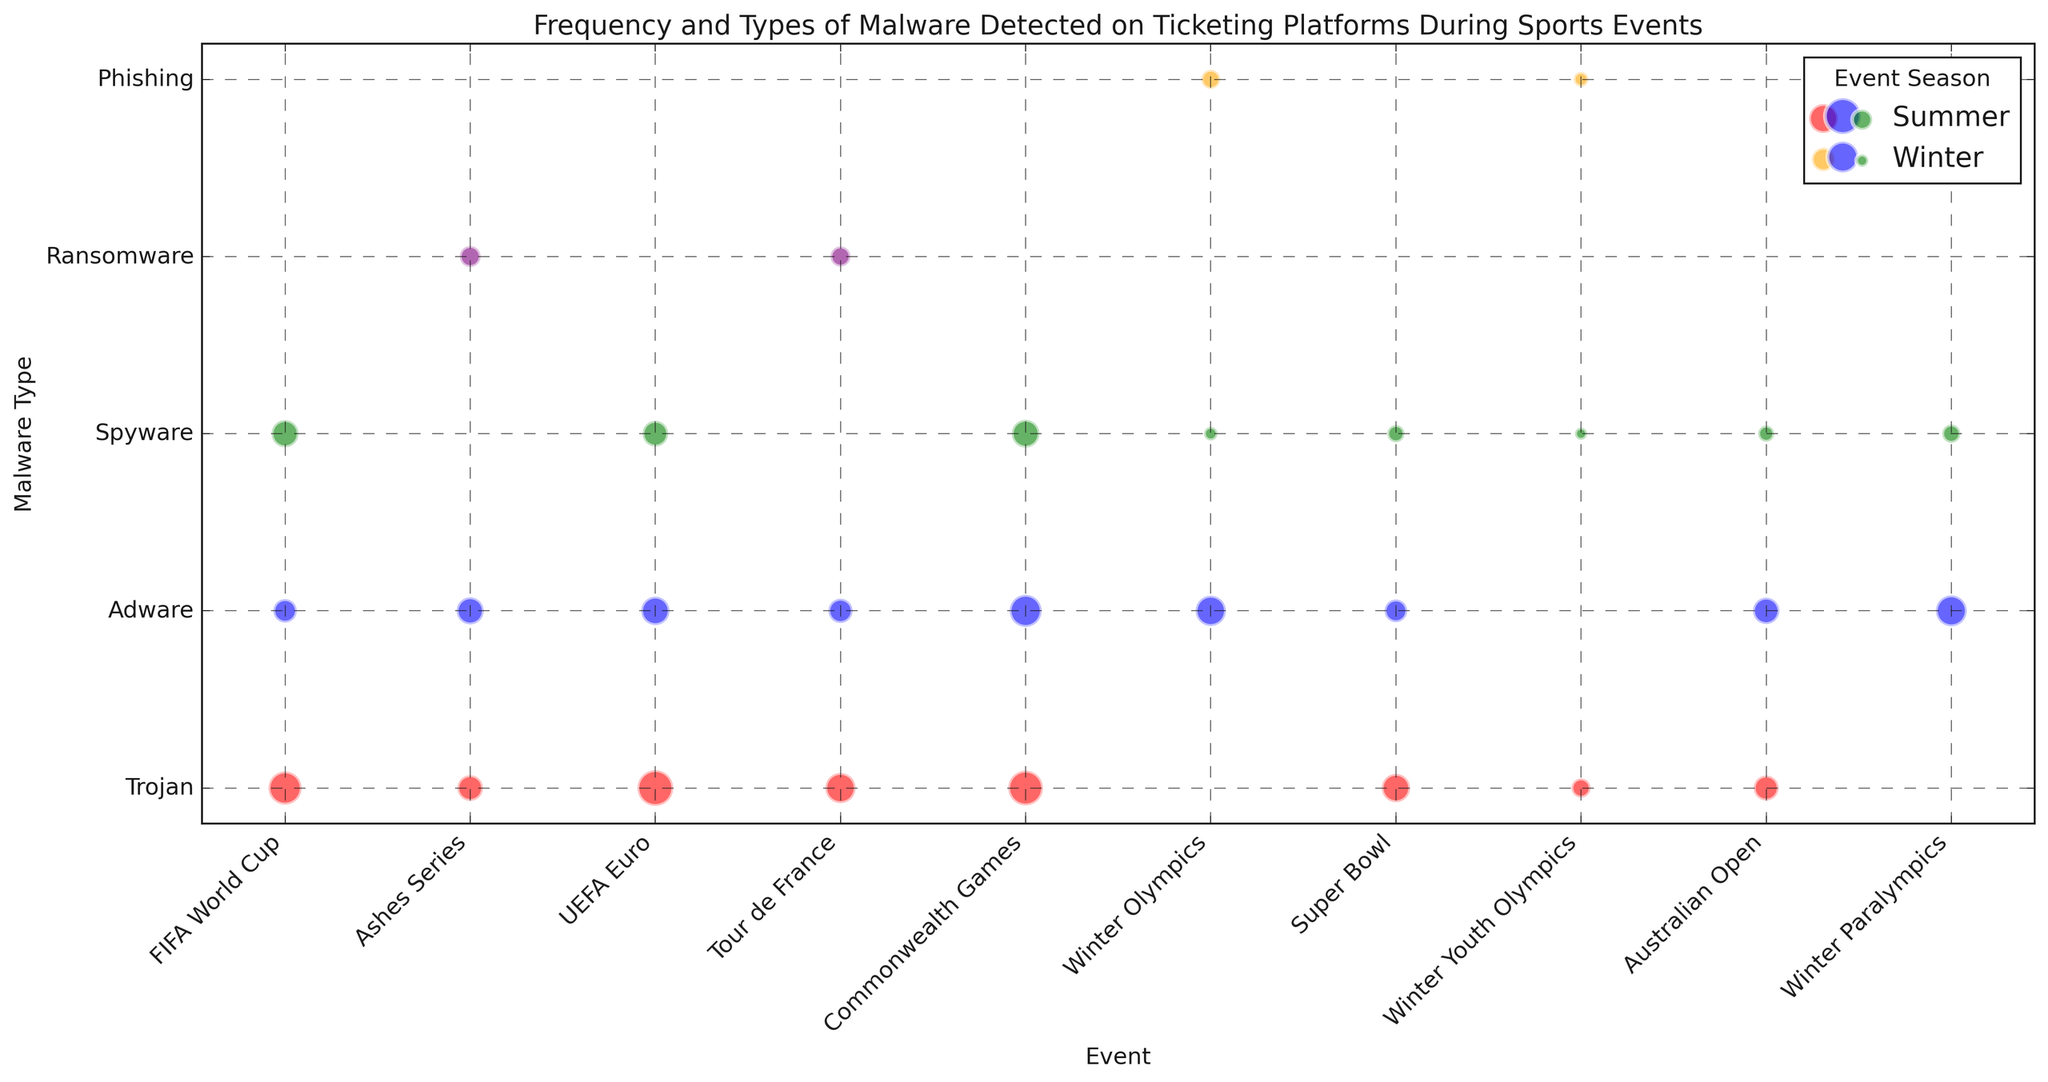Which event season had the highest frequency of malware detections overall? We need to examine the size of the bubbles corresponding to different event seasons. The 2022 Summer Commonwealth Games has the largest bubbles, indicating the highest frequency of malware detections.
Answer: 2022 Summer What is the malware type most frequently detected during the 2020 Summer UEFA Euro? Look for the event "UEFA Euro" under "2020 Summer" and compare the size of the bubbles. The largest bubble corresponds to "Trojan".
Answer: Trojan Between 2018 Winter Olympics and 2020 Winter Youth Olympics, which event had a higher combined detection frequency of Ransomware and Adware? Sum the frequency of Ransomware and Adware for both events. 2018 Winter Olympics (Ransomware: 10 + Adware: 25 = 35) and 2020 Winter Youth Olympics (Ransomware: 6 + Adware: 0 = 6). Hence, 2018 Winter Olympics had higher combined detections.
Answer: 2018 Winter Olympics Which event and malware type combination had the lowest frequency detected? Identify the smallest bubble on the chart. The smallest bubbles are for "Winter Youth Olympics" under "2020 Winter", for "Spyware" and "Ransomware", both sized equally small.
Answer: Winter Youth Olympics, Spyware & Ransomware In which event season was Spyware most frequently detected? Compare the size of the bubbles for "Spyware" across all seasons. The largest "Spyware" bubble appears in the 2022 Summer Commonwealth Games.
Answer: 2022 Summer Are there any malware types that were detected in all event seasons (both Summer and Winter) within a single year? Check each year individually for malware types appearing in both summer and winter events. Spyware is detected in both seasons of every year.
Answer: Spyware How does the detection frequency of Trojans in the 2018 FIFA World Cup compare to the 2020 UEFA Euro? Compare the size of the red bubbles in the "FIFA World Cup" under "2018 Summer" and "UEFA Euro" under "2020 Summer". The frequency for FIFA World Cup is 30 and for UEFA Euro is 35, so UEFA Euro is higher.
Answer: Higher in 2020 UEFA Euro What is the average detection frequency of Adware across all events? Sum the frequency of Adware detections and divide by the number of events. Summing all Adware values: (15 + 25 + 20 + 14 + 22 + 19 + 28 + 26) = 169. There are 8 events with Adware detections, so the average is 169/8 = 21.
Answer: 21 Which two events have the closest frequency of Trojan detections? Analyze the size of the "Trojan" bubbles for all events and find the two closest in size. "Australian Open" (17) and "Ashes Series" (18) have the closest frequencies, with a difference of just 1.
Answer: Australian Open and Ashes Series What is the visual similarity between malware detections in the Winter Paralympics and Winter Olympics? Compare the bubble sizes and colors for events under "Winter Paralympics" and "Winter Olympics". Both have medium-sized blue bubbles for "Adware", orange bubble for "Ransomware" present, and small-sized green bubbles for "Spyware".
Answer: Medium Adware, Ransomware present, Small Spyware 